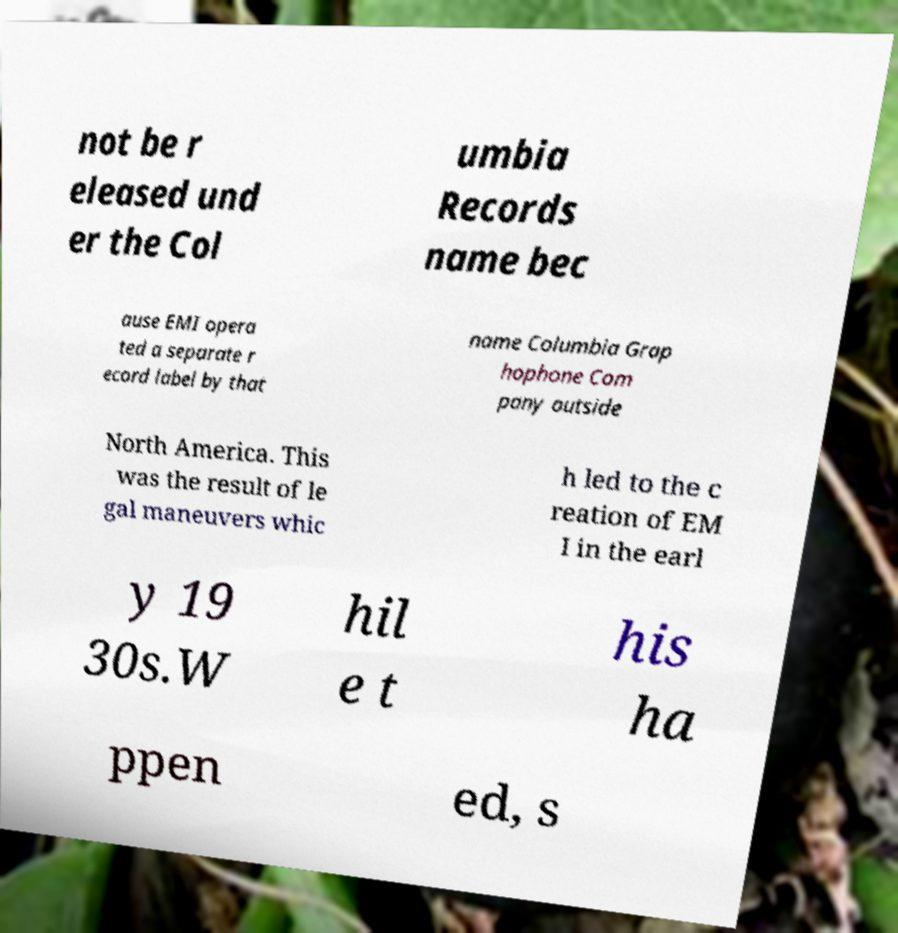Can you accurately transcribe the text from the provided image for me? not be r eleased und er the Col umbia Records name bec ause EMI opera ted a separate r ecord label by that name Columbia Grap hophone Com pany outside North America. This was the result of le gal maneuvers whic h led to the c reation of EM I in the earl y 19 30s.W hil e t his ha ppen ed, s 